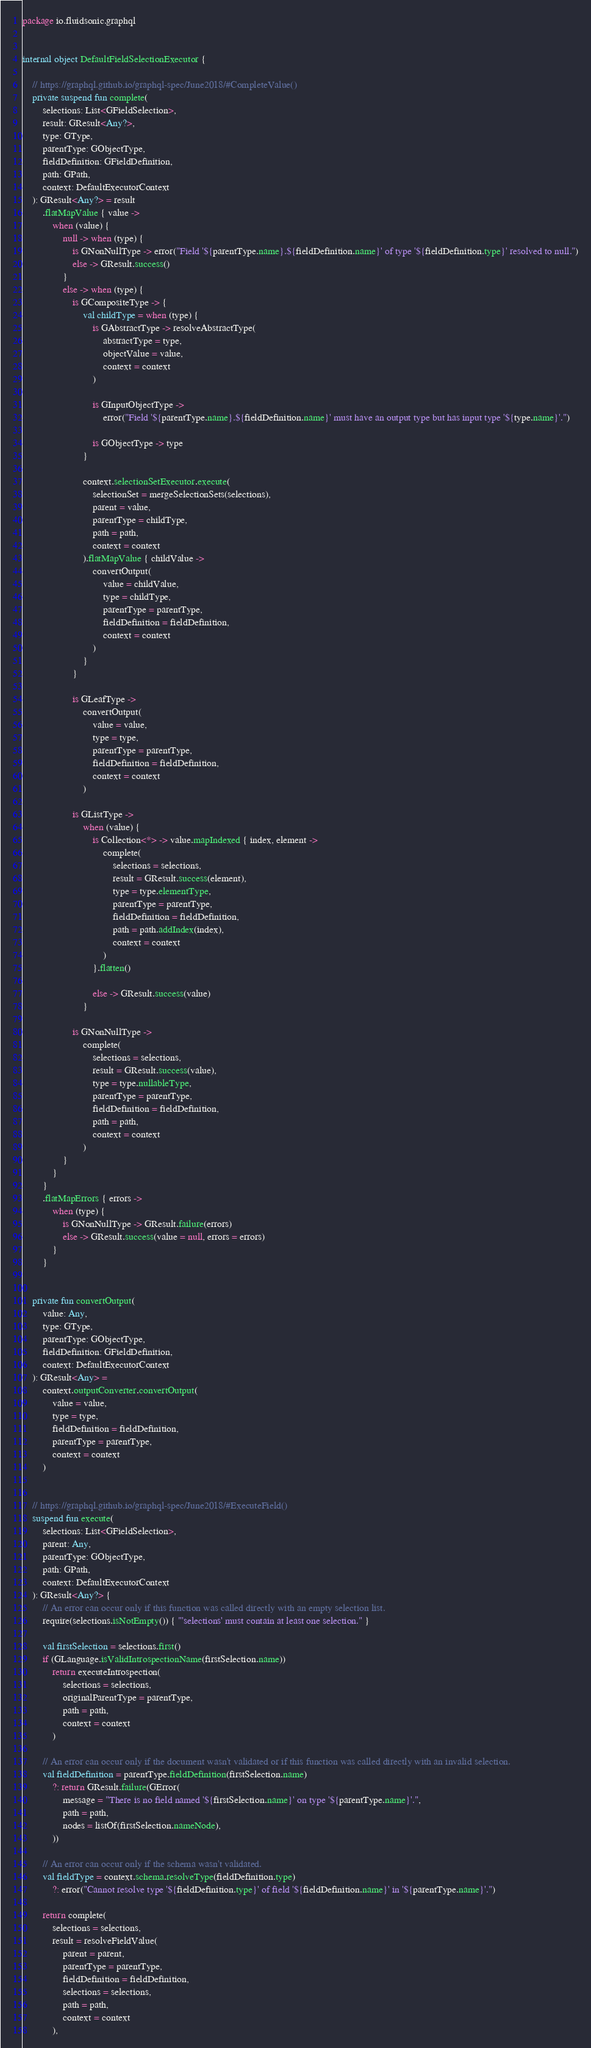Convert code to text. <code><loc_0><loc_0><loc_500><loc_500><_Kotlin_>package io.fluidsonic.graphql


internal object DefaultFieldSelectionExecutor {

	// https://graphql.github.io/graphql-spec/June2018/#CompleteValue()
	private suspend fun complete(
		selections: List<GFieldSelection>,
		result: GResult<Any?>,
		type: GType,
		parentType: GObjectType,
		fieldDefinition: GFieldDefinition,
		path: GPath,
		context: DefaultExecutorContext
	): GResult<Any?> = result
		.flatMapValue { value ->
			when (value) {
				null -> when (type) {
					is GNonNullType -> error("Field '${parentType.name}.${fieldDefinition.name}' of type '${fieldDefinition.type}' resolved to null.")
					else -> GResult.success()
				}
				else -> when (type) {
					is GCompositeType -> {
						val childType = when (type) {
							is GAbstractType -> resolveAbstractType(
								abstractType = type,
								objectValue = value,
								context = context
							)

							is GInputObjectType ->
								error("Field '${parentType.name}.${fieldDefinition.name}' must have an output type but has input type '${type.name}'.")

							is GObjectType -> type
						}

						context.selectionSetExecutor.execute(
							selectionSet = mergeSelectionSets(selections),
							parent = value,
							parentType = childType,
							path = path,
							context = context
						).flatMapValue { childValue ->
							convertOutput(
								value = childValue,
								type = childType,
								parentType = parentType,
								fieldDefinition = fieldDefinition,
								context = context
							)
						}
					}

					is GLeafType ->
						convertOutput(
							value = value,
							type = type,
							parentType = parentType,
							fieldDefinition = fieldDefinition,
							context = context
						)

					is GListType ->
						when (value) {
							is Collection<*> -> value.mapIndexed { index, element ->
								complete(
									selections = selections,
									result = GResult.success(element),
									type = type.elementType,
									parentType = parentType,
									fieldDefinition = fieldDefinition,
									path = path.addIndex(index),
									context = context
								)
							}.flatten()

							else -> GResult.success(value)
						}

					is GNonNullType ->
						complete(
							selections = selections,
							result = GResult.success(value),
							type = type.nullableType,
							parentType = parentType,
							fieldDefinition = fieldDefinition,
							path = path,
							context = context
						)
				}
			}
		}
		.flatMapErrors { errors ->
			when (type) {
				is GNonNullType -> GResult.failure(errors)
				else -> GResult.success(value = null, errors = errors)
			}
		}


	private fun convertOutput(
		value: Any,
		type: GType,
		parentType: GObjectType,
		fieldDefinition: GFieldDefinition,
		context: DefaultExecutorContext
	): GResult<Any> =
		context.outputConverter.convertOutput(
			value = value,
			type = type,
			fieldDefinition = fieldDefinition,
			parentType = parentType,
			context = context
		)


	// https://graphql.github.io/graphql-spec/June2018/#ExecuteField()
	suspend fun execute(
		selections: List<GFieldSelection>,
		parent: Any,
		parentType: GObjectType,
		path: GPath,
		context: DefaultExecutorContext
	): GResult<Any?> {
		// An error can occur only if this function was called directly with an empty selection list.
		require(selections.isNotEmpty()) { "'selections' must contain at least one selection." }

		val firstSelection = selections.first()
		if (GLanguage.isValidIntrospectionName(firstSelection.name))
			return executeIntrospection(
				selections = selections,
				originalParentType = parentType,
				path = path,
				context = context
			)

		// An error can occur only if the document wasn't validated or if this function was called directly with an invalid selection.
		val fieldDefinition = parentType.fieldDefinition(firstSelection.name)
			?: return GResult.failure(GError(
				message = "There is no field named '${firstSelection.name}' on type '${parentType.name}'.",
				path = path,
				nodes = listOf(firstSelection.nameNode),
			))

		// An error can occur only if the schema wasn't validated.
		val fieldType = context.schema.resolveType(fieldDefinition.type)
			?: error("Cannot resolve type '${fieldDefinition.type}' of field '${fieldDefinition.name}' in '${parentType.name}'.")

		return complete(
			selections = selections,
			result = resolveFieldValue(
				parent = parent,
				parentType = parentType,
				fieldDefinition = fieldDefinition,
				selections = selections,
				path = path,
				context = context
			),</code> 